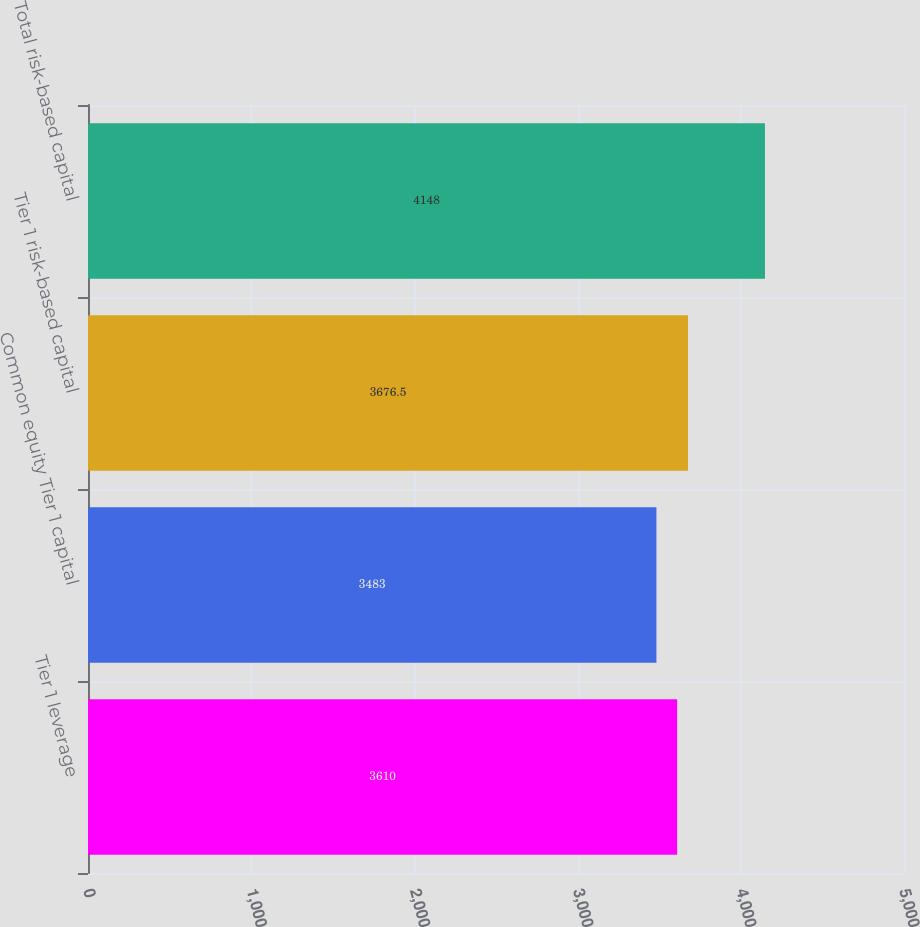Convert chart. <chart><loc_0><loc_0><loc_500><loc_500><bar_chart><fcel>Tier 1 leverage<fcel>Common equity Tier 1 capital<fcel>Tier 1 risk-based capital<fcel>Total risk-based capital<nl><fcel>3610<fcel>3483<fcel>3676.5<fcel>4148<nl></chart> 